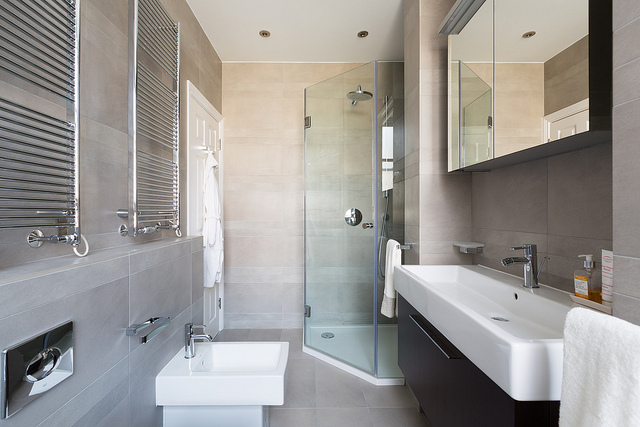How many sandwich on the plate? There appears to be a misunderstanding as there is no plate or sandwich visible in the image. The image shows a modern bathroom with no food items present. 